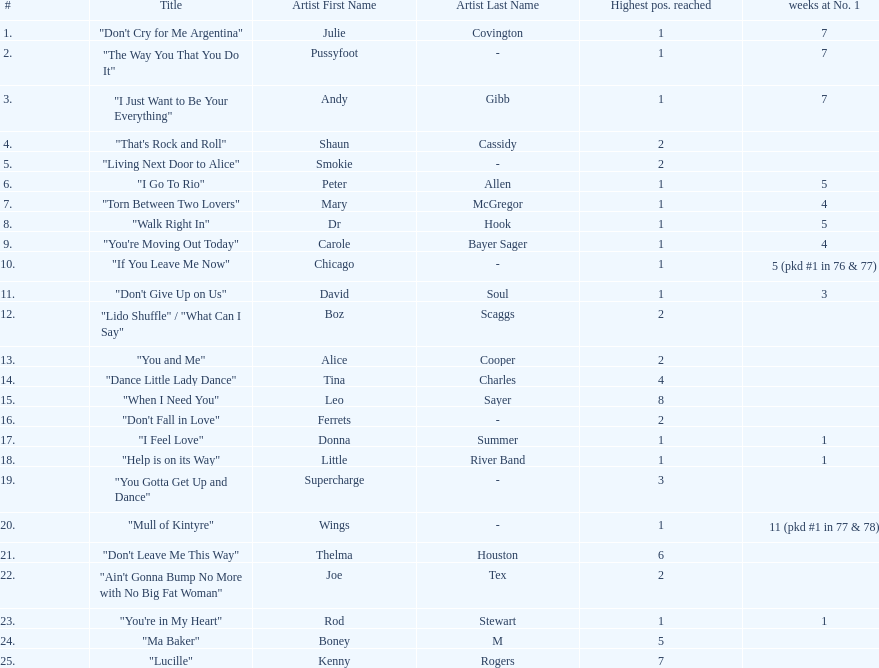How many songs in the table only reached position number 2? 6. 